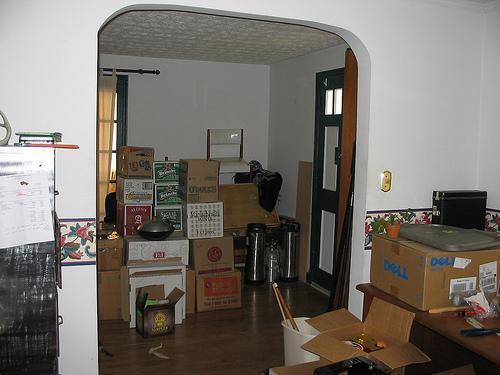How many doors are visible?
Give a very brief answer. 1. 